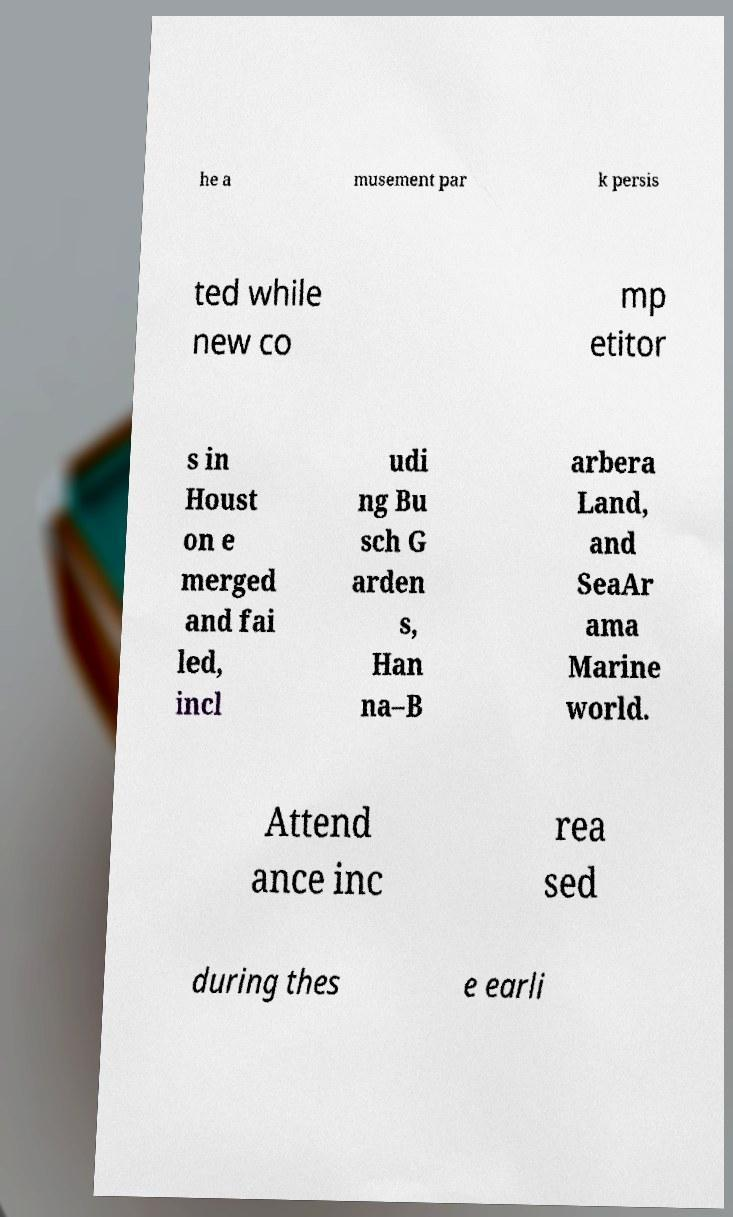Could you extract and type out the text from this image? he a musement par k persis ted while new co mp etitor s in Houst on e merged and fai led, incl udi ng Bu sch G arden s, Han na–B arbera Land, and SeaAr ama Marine world. Attend ance inc rea sed during thes e earli 